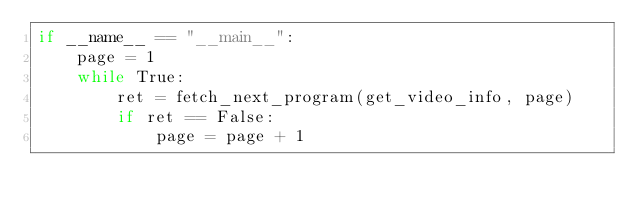Convert code to text. <code><loc_0><loc_0><loc_500><loc_500><_Python_>if __name__ == "__main__":
    page = 1
    while True:
        ret = fetch_next_program(get_video_info, page)
        if ret == False:
            page = page + 1
</code> 